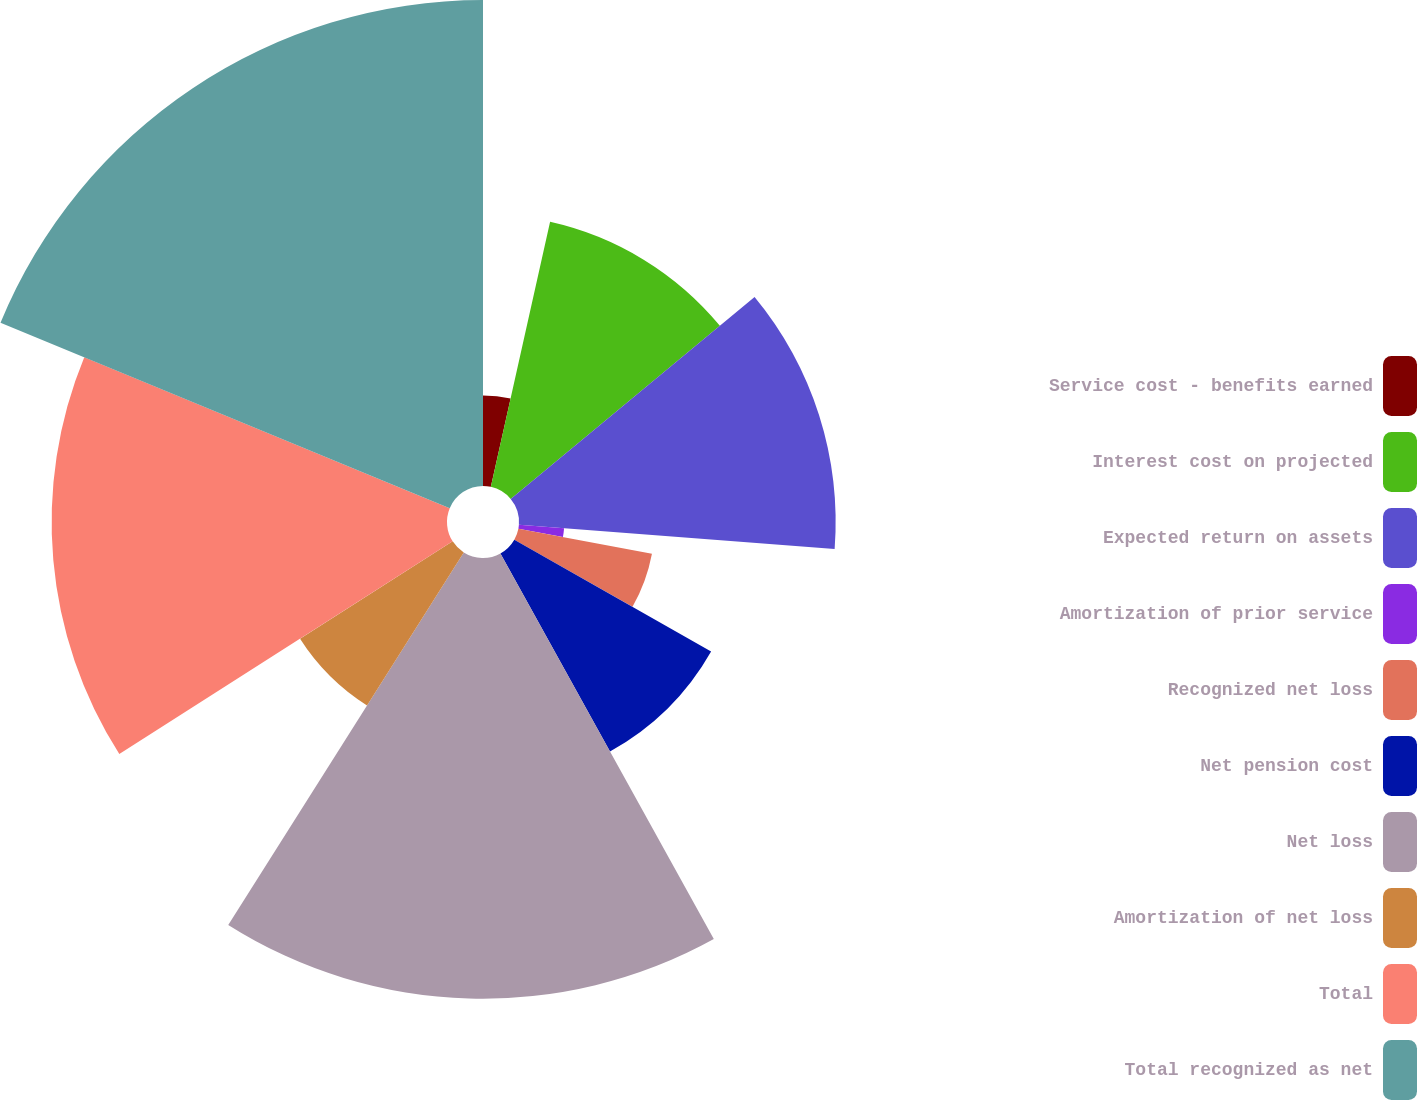Convert chart to OTSL. <chart><loc_0><loc_0><loc_500><loc_500><pie_chart><fcel>Service cost - benefits earned<fcel>Interest cost on projected<fcel>Expected return on assets<fcel>Amortization of prior service<fcel>Recognized net loss<fcel>Net pension cost<fcel>Net loss<fcel>Amortization of net loss<fcel>Total<fcel>Total recognized as net<nl><fcel>3.5%<fcel>10.49%<fcel>12.23%<fcel>1.75%<fcel>5.25%<fcel>8.74%<fcel>17.02%<fcel>6.99%<fcel>15.27%<fcel>18.77%<nl></chart> 